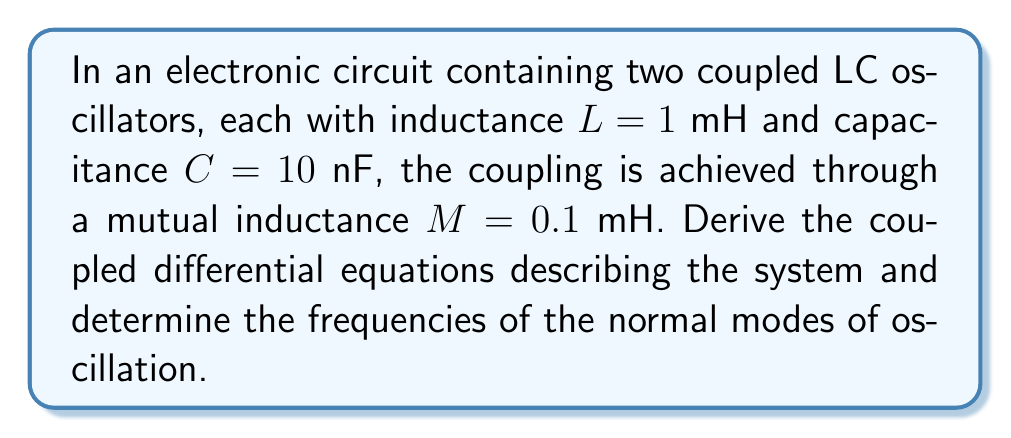Could you help me with this problem? 1. First, let's write the equations for each individual LC oscillator:
   $$\frac{d^2q_1}{dt^2} + \frac{1}{LC}q_1 = 0$$
   $$\frac{d^2q_2}{dt^2} + \frac{1}{LC}q_2 = 0$$

2. Now, we introduce the coupling through mutual inductance. The voltage across each inductor is affected by the current in the other:
   $$L\frac{di_1}{dt} + M\frac{di_2}{dt} = v_1$$
   $$L\frac{di_2}{dt} + M\frac{di_1}{dt} = v_2$$

3. Substituting $i = \frac{dq}{dt}$ and $v = \frac{q}{C}$, we get:
   $$L\frac{d^2q_1}{dt^2} + M\frac{d^2q_2}{dt^2} = \frac{q_1}{C}$$
   $$L\frac{d^2q_2}{dt^2} + M\frac{d^2q_1}{dt^2} = \frac{q_2}{C}$$

4. Rearranging these equations:
   $$(L-M)\frac{d^2q_1}{dt^2} + \frac{q_1}{C} = M\frac{d^2q_2}{dt^2}$$
   $$(L-M)\frac{d^2q_2}{dt^2} + \frac{q_2}{C} = M\frac{d^2q_1}{dt^2}$$

5. To find the normal modes, we assume solutions of the form $q_1 = A_1e^{i\omega t}$ and $q_2 = A_2e^{i\omega t}$. Substituting these into our equations:
   $$(-\omega^2(L-M) + \frac{1}{C})A_1 = -\omega^2MA_2$$
   $$(-\omega^2(L-M) + \frac{1}{C})A_2 = -\omega^2MA_1$$

6. For non-trivial solutions, the determinant of this system must be zero:
   $$\begin{vmatrix}
   -\omega^2(L-M) + \frac{1}{C} & \omega^2M \\
   \omega^2M & -\omega^2(L-M) + \frac{1}{C}
   \end{vmatrix} = 0$$

7. Solving this determinant equation:
   $$(-\omega^2(L-M) + \frac{1}{C})^2 - (\omega^2M)^2 = 0$$

8. This can be factored into:
   $$(-\omega^2(L-M) + \frac{1}{C} - \omega^2M)(-\omega^2(L-M) + \frac{1}{C} + \omega^2M) = 0$$

9. Solving each factor:
   $$\omega_1^2 = \frac{1}{LC-MC} = \frac{1}{C(L-M)}$$
   $$\omega_2^2 = \frac{1}{LC+MC} = \frac{1}{C(L+M)}$$

10. Substituting the given values:
    $$\omega_1 = \sqrt{\frac{1}{(1 \times 10^{-3})(10 \times 10^{-9}) - (0.1 \times 10^{-3})(10 \times 10^{-9})}} = 3.33 \times 10^5 \text{ rad/s}$$
    $$\omega_2 = \sqrt{\frac{1}{(1 \times 10^{-3})(10 \times 10^{-9}) + (0.1 \times 10^{-3})(10 \times 10^{-9})}} = 3.02 \times 10^5 \text{ rad/s}$$

11. Converting to frequencies in Hz:
    $$f_1 = \frac{\omega_1}{2\pi} = 53.0 \text{ kHz}$$
    $$f_2 = \frac{\omega_2}{2\pi} = 48.1 \text{ kHz}$$
Answer: $f_1 = 53.0 \text{ kHz}, f_2 = 48.1 \text{ kHz}$ 